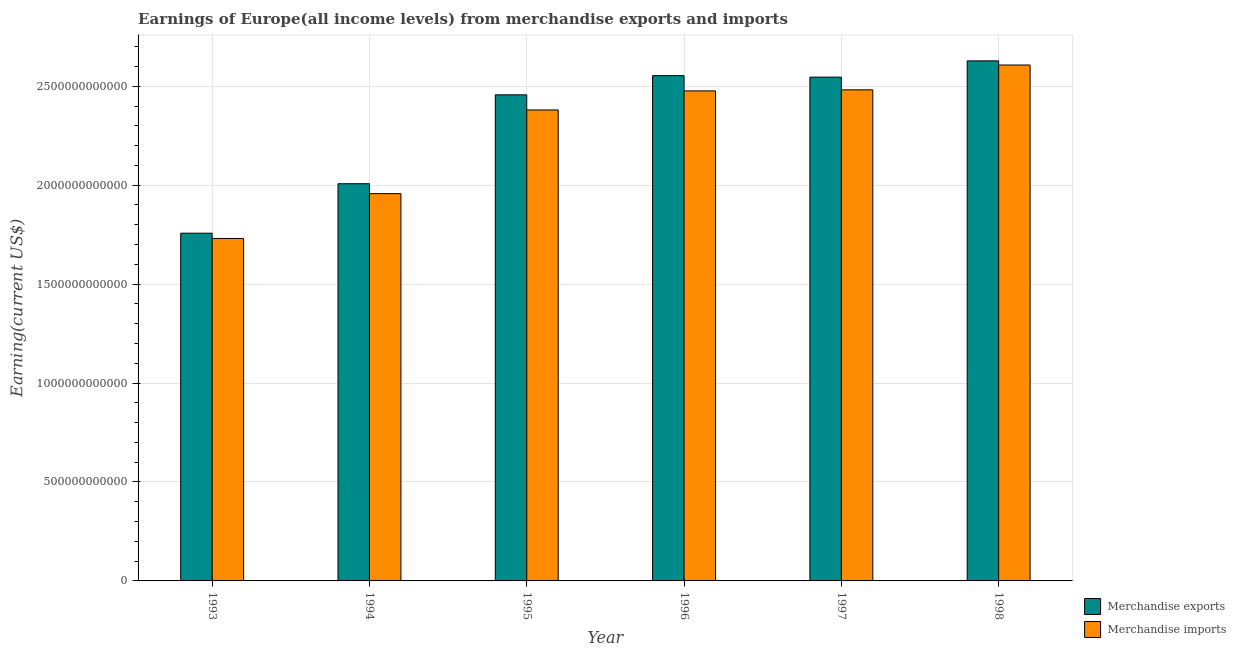How many groups of bars are there?
Provide a succinct answer. 6. What is the earnings from merchandise exports in 1998?
Offer a terse response. 2.63e+12. Across all years, what is the maximum earnings from merchandise exports?
Give a very brief answer. 2.63e+12. Across all years, what is the minimum earnings from merchandise exports?
Ensure brevity in your answer.  1.76e+12. In which year was the earnings from merchandise imports maximum?
Keep it short and to the point. 1998. What is the total earnings from merchandise exports in the graph?
Provide a short and direct response. 1.39e+13. What is the difference between the earnings from merchandise exports in 1995 and that in 1998?
Provide a succinct answer. -1.72e+11. What is the difference between the earnings from merchandise imports in 1996 and the earnings from merchandise exports in 1995?
Provide a short and direct response. 9.63e+1. What is the average earnings from merchandise imports per year?
Your answer should be very brief. 2.27e+12. In the year 1995, what is the difference between the earnings from merchandise exports and earnings from merchandise imports?
Give a very brief answer. 0. What is the ratio of the earnings from merchandise imports in 1993 to that in 1998?
Your response must be concise. 0.66. What is the difference between the highest and the second highest earnings from merchandise imports?
Offer a terse response. 1.26e+11. What is the difference between the highest and the lowest earnings from merchandise imports?
Keep it short and to the point. 8.77e+11. What does the 1st bar from the left in 1995 represents?
Keep it short and to the point. Merchandise exports. How many bars are there?
Ensure brevity in your answer.  12. Are all the bars in the graph horizontal?
Ensure brevity in your answer.  No. What is the difference between two consecutive major ticks on the Y-axis?
Your answer should be compact. 5.00e+11. Are the values on the major ticks of Y-axis written in scientific E-notation?
Make the answer very short. No. Does the graph contain any zero values?
Keep it short and to the point. No. Does the graph contain grids?
Make the answer very short. Yes. Where does the legend appear in the graph?
Your answer should be very brief. Bottom right. How are the legend labels stacked?
Provide a succinct answer. Vertical. What is the title of the graph?
Offer a terse response. Earnings of Europe(all income levels) from merchandise exports and imports. What is the label or title of the Y-axis?
Offer a very short reply. Earning(current US$). What is the Earning(current US$) of Merchandise exports in 1993?
Offer a terse response. 1.76e+12. What is the Earning(current US$) in Merchandise imports in 1993?
Ensure brevity in your answer.  1.73e+12. What is the Earning(current US$) in Merchandise exports in 1994?
Provide a succinct answer. 2.01e+12. What is the Earning(current US$) in Merchandise imports in 1994?
Give a very brief answer. 1.96e+12. What is the Earning(current US$) in Merchandise exports in 1995?
Provide a succinct answer. 2.46e+12. What is the Earning(current US$) of Merchandise imports in 1995?
Give a very brief answer. 2.38e+12. What is the Earning(current US$) of Merchandise exports in 1996?
Offer a terse response. 2.55e+12. What is the Earning(current US$) of Merchandise imports in 1996?
Your answer should be very brief. 2.48e+12. What is the Earning(current US$) of Merchandise exports in 1997?
Your response must be concise. 2.55e+12. What is the Earning(current US$) in Merchandise imports in 1997?
Your answer should be compact. 2.48e+12. What is the Earning(current US$) in Merchandise exports in 1998?
Keep it short and to the point. 2.63e+12. What is the Earning(current US$) in Merchandise imports in 1998?
Your answer should be very brief. 2.61e+12. Across all years, what is the maximum Earning(current US$) of Merchandise exports?
Keep it short and to the point. 2.63e+12. Across all years, what is the maximum Earning(current US$) of Merchandise imports?
Your response must be concise. 2.61e+12. Across all years, what is the minimum Earning(current US$) in Merchandise exports?
Ensure brevity in your answer.  1.76e+12. Across all years, what is the minimum Earning(current US$) in Merchandise imports?
Your answer should be very brief. 1.73e+12. What is the total Earning(current US$) of Merchandise exports in the graph?
Offer a very short reply. 1.39e+13. What is the total Earning(current US$) of Merchandise imports in the graph?
Make the answer very short. 1.36e+13. What is the difference between the Earning(current US$) of Merchandise exports in 1993 and that in 1994?
Keep it short and to the point. -2.50e+11. What is the difference between the Earning(current US$) of Merchandise imports in 1993 and that in 1994?
Ensure brevity in your answer.  -2.27e+11. What is the difference between the Earning(current US$) in Merchandise exports in 1993 and that in 1995?
Your answer should be compact. -6.99e+11. What is the difference between the Earning(current US$) in Merchandise imports in 1993 and that in 1995?
Your answer should be compact. -6.49e+11. What is the difference between the Earning(current US$) in Merchandise exports in 1993 and that in 1996?
Provide a succinct answer. -7.96e+11. What is the difference between the Earning(current US$) of Merchandise imports in 1993 and that in 1996?
Your answer should be very brief. -7.46e+11. What is the difference between the Earning(current US$) of Merchandise exports in 1993 and that in 1997?
Your response must be concise. -7.89e+11. What is the difference between the Earning(current US$) in Merchandise imports in 1993 and that in 1997?
Your answer should be very brief. -7.51e+11. What is the difference between the Earning(current US$) of Merchandise exports in 1993 and that in 1998?
Offer a very short reply. -8.71e+11. What is the difference between the Earning(current US$) of Merchandise imports in 1993 and that in 1998?
Make the answer very short. -8.77e+11. What is the difference between the Earning(current US$) of Merchandise exports in 1994 and that in 1995?
Provide a succinct answer. -4.49e+11. What is the difference between the Earning(current US$) in Merchandise imports in 1994 and that in 1995?
Offer a very short reply. -4.23e+11. What is the difference between the Earning(current US$) of Merchandise exports in 1994 and that in 1996?
Provide a succinct answer. -5.46e+11. What is the difference between the Earning(current US$) of Merchandise imports in 1994 and that in 1996?
Provide a short and direct response. -5.19e+11. What is the difference between the Earning(current US$) of Merchandise exports in 1994 and that in 1997?
Provide a succinct answer. -5.39e+11. What is the difference between the Earning(current US$) of Merchandise imports in 1994 and that in 1997?
Offer a very short reply. -5.25e+11. What is the difference between the Earning(current US$) in Merchandise exports in 1994 and that in 1998?
Provide a short and direct response. -6.21e+11. What is the difference between the Earning(current US$) in Merchandise imports in 1994 and that in 1998?
Offer a very short reply. -6.50e+11. What is the difference between the Earning(current US$) of Merchandise exports in 1995 and that in 1996?
Ensure brevity in your answer.  -9.69e+1. What is the difference between the Earning(current US$) in Merchandise imports in 1995 and that in 1996?
Your answer should be very brief. -9.63e+1. What is the difference between the Earning(current US$) in Merchandise exports in 1995 and that in 1997?
Provide a short and direct response. -8.94e+1. What is the difference between the Earning(current US$) in Merchandise imports in 1995 and that in 1997?
Your response must be concise. -1.02e+11. What is the difference between the Earning(current US$) in Merchandise exports in 1995 and that in 1998?
Offer a terse response. -1.72e+11. What is the difference between the Earning(current US$) in Merchandise imports in 1995 and that in 1998?
Offer a terse response. -2.27e+11. What is the difference between the Earning(current US$) in Merchandise exports in 1996 and that in 1997?
Provide a short and direct response. 7.46e+09. What is the difference between the Earning(current US$) in Merchandise imports in 1996 and that in 1997?
Offer a very short reply. -5.28e+09. What is the difference between the Earning(current US$) in Merchandise exports in 1996 and that in 1998?
Ensure brevity in your answer.  -7.47e+1. What is the difference between the Earning(current US$) of Merchandise imports in 1996 and that in 1998?
Make the answer very short. -1.31e+11. What is the difference between the Earning(current US$) in Merchandise exports in 1997 and that in 1998?
Offer a terse response. -8.21e+1. What is the difference between the Earning(current US$) in Merchandise imports in 1997 and that in 1998?
Offer a terse response. -1.26e+11. What is the difference between the Earning(current US$) in Merchandise exports in 1993 and the Earning(current US$) in Merchandise imports in 1994?
Make the answer very short. -2.00e+11. What is the difference between the Earning(current US$) of Merchandise exports in 1993 and the Earning(current US$) of Merchandise imports in 1995?
Ensure brevity in your answer.  -6.23e+11. What is the difference between the Earning(current US$) of Merchandise exports in 1993 and the Earning(current US$) of Merchandise imports in 1996?
Make the answer very short. -7.19e+11. What is the difference between the Earning(current US$) in Merchandise exports in 1993 and the Earning(current US$) in Merchandise imports in 1997?
Offer a very short reply. -7.24e+11. What is the difference between the Earning(current US$) in Merchandise exports in 1993 and the Earning(current US$) in Merchandise imports in 1998?
Keep it short and to the point. -8.50e+11. What is the difference between the Earning(current US$) in Merchandise exports in 1994 and the Earning(current US$) in Merchandise imports in 1995?
Provide a succinct answer. -3.73e+11. What is the difference between the Earning(current US$) in Merchandise exports in 1994 and the Earning(current US$) in Merchandise imports in 1996?
Provide a succinct answer. -4.69e+11. What is the difference between the Earning(current US$) of Merchandise exports in 1994 and the Earning(current US$) of Merchandise imports in 1997?
Provide a short and direct response. -4.74e+11. What is the difference between the Earning(current US$) in Merchandise exports in 1994 and the Earning(current US$) in Merchandise imports in 1998?
Offer a terse response. -6.00e+11. What is the difference between the Earning(current US$) of Merchandise exports in 1995 and the Earning(current US$) of Merchandise imports in 1996?
Offer a terse response. -1.98e+1. What is the difference between the Earning(current US$) of Merchandise exports in 1995 and the Earning(current US$) of Merchandise imports in 1997?
Keep it short and to the point. -2.51e+1. What is the difference between the Earning(current US$) in Merchandise exports in 1995 and the Earning(current US$) in Merchandise imports in 1998?
Provide a succinct answer. -1.51e+11. What is the difference between the Earning(current US$) of Merchandise exports in 1996 and the Earning(current US$) of Merchandise imports in 1997?
Your answer should be compact. 7.18e+1. What is the difference between the Earning(current US$) in Merchandise exports in 1996 and the Earning(current US$) in Merchandise imports in 1998?
Ensure brevity in your answer.  -5.38e+1. What is the difference between the Earning(current US$) of Merchandise exports in 1997 and the Earning(current US$) of Merchandise imports in 1998?
Your response must be concise. -6.12e+1. What is the average Earning(current US$) of Merchandise exports per year?
Offer a terse response. 2.32e+12. What is the average Earning(current US$) of Merchandise imports per year?
Your answer should be very brief. 2.27e+12. In the year 1993, what is the difference between the Earning(current US$) of Merchandise exports and Earning(current US$) of Merchandise imports?
Make the answer very short. 2.66e+1. In the year 1994, what is the difference between the Earning(current US$) of Merchandise exports and Earning(current US$) of Merchandise imports?
Offer a very short reply. 5.01e+1. In the year 1995, what is the difference between the Earning(current US$) of Merchandise exports and Earning(current US$) of Merchandise imports?
Your answer should be very brief. 7.65e+1. In the year 1996, what is the difference between the Earning(current US$) in Merchandise exports and Earning(current US$) in Merchandise imports?
Provide a short and direct response. 7.70e+1. In the year 1997, what is the difference between the Earning(current US$) in Merchandise exports and Earning(current US$) in Merchandise imports?
Keep it short and to the point. 6.43e+1. In the year 1998, what is the difference between the Earning(current US$) of Merchandise exports and Earning(current US$) of Merchandise imports?
Offer a terse response. 2.09e+1. What is the ratio of the Earning(current US$) in Merchandise exports in 1993 to that in 1994?
Your answer should be very brief. 0.88. What is the ratio of the Earning(current US$) in Merchandise imports in 1993 to that in 1994?
Your response must be concise. 0.88. What is the ratio of the Earning(current US$) of Merchandise exports in 1993 to that in 1995?
Offer a very short reply. 0.72. What is the ratio of the Earning(current US$) of Merchandise imports in 1993 to that in 1995?
Offer a terse response. 0.73. What is the ratio of the Earning(current US$) in Merchandise exports in 1993 to that in 1996?
Give a very brief answer. 0.69. What is the ratio of the Earning(current US$) in Merchandise imports in 1993 to that in 1996?
Make the answer very short. 0.7. What is the ratio of the Earning(current US$) of Merchandise exports in 1993 to that in 1997?
Offer a terse response. 0.69. What is the ratio of the Earning(current US$) in Merchandise imports in 1993 to that in 1997?
Offer a very short reply. 0.7. What is the ratio of the Earning(current US$) in Merchandise exports in 1993 to that in 1998?
Your answer should be very brief. 0.67. What is the ratio of the Earning(current US$) in Merchandise imports in 1993 to that in 1998?
Give a very brief answer. 0.66. What is the ratio of the Earning(current US$) in Merchandise exports in 1994 to that in 1995?
Make the answer very short. 0.82. What is the ratio of the Earning(current US$) in Merchandise imports in 1994 to that in 1995?
Offer a very short reply. 0.82. What is the ratio of the Earning(current US$) of Merchandise exports in 1994 to that in 1996?
Your answer should be compact. 0.79. What is the ratio of the Earning(current US$) of Merchandise imports in 1994 to that in 1996?
Offer a terse response. 0.79. What is the ratio of the Earning(current US$) in Merchandise exports in 1994 to that in 1997?
Provide a succinct answer. 0.79. What is the ratio of the Earning(current US$) in Merchandise imports in 1994 to that in 1997?
Your answer should be compact. 0.79. What is the ratio of the Earning(current US$) of Merchandise exports in 1994 to that in 1998?
Your answer should be compact. 0.76. What is the ratio of the Earning(current US$) of Merchandise imports in 1994 to that in 1998?
Make the answer very short. 0.75. What is the ratio of the Earning(current US$) in Merchandise exports in 1995 to that in 1996?
Your response must be concise. 0.96. What is the ratio of the Earning(current US$) in Merchandise imports in 1995 to that in 1996?
Ensure brevity in your answer.  0.96. What is the ratio of the Earning(current US$) in Merchandise exports in 1995 to that in 1997?
Provide a succinct answer. 0.96. What is the ratio of the Earning(current US$) in Merchandise imports in 1995 to that in 1997?
Keep it short and to the point. 0.96. What is the ratio of the Earning(current US$) of Merchandise exports in 1995 to that in 1998?
Offer a terse response. 0.93. What is the ratio of the Earning(current US$) in Merchandise imports in 1995 to that in 1998?
Offer a terse response. 0.91. What is the ratio of the Earning(current US$) of Merchandise exports in 1996 to that in 1997?
Make the answer very short. 1. What is the ratio of the Earning(current US$) in Merchandise imports in 1996 to that in 1997?
Your answer should be very brief. 1. What is the ratio of the Earning(current US$) in Merchandise exports in 1996 to that in 1998?
Provide a short and direct response. 0.97. What is the ratio of the Earning(current US$) in Merchandise imports in 1996 to that in 1998?
Provide a succinct answer. 0.95. What is the ratio of the Earning(current US$) of Merchandise exports in 1997 to that in 1998?
Your response must be concise. 0.97. What is the ratio of the Earning(current US$) in Merchandise imports in 1997 to that in 1998?
Ensure brevity in your answer.  0.95. What is the difference between the highest and the second highest Earning(current US$) in Merchandise exports?
Offer a terse response. 7.47e+1. What is the difference between the highest and the second highest Earning(current US$) in Merchandise imports?
Your response must be concise. 1.26e+11. What is the difference between the highest and the lowest Earning(current US$) in Merchandise exports?
Give a very brief answer. 8.71e+11. What is the difference between the highest and the lowest Earning(current US$) in Merchandise imports?
Keep it short and to the point. 8.77e+11. 